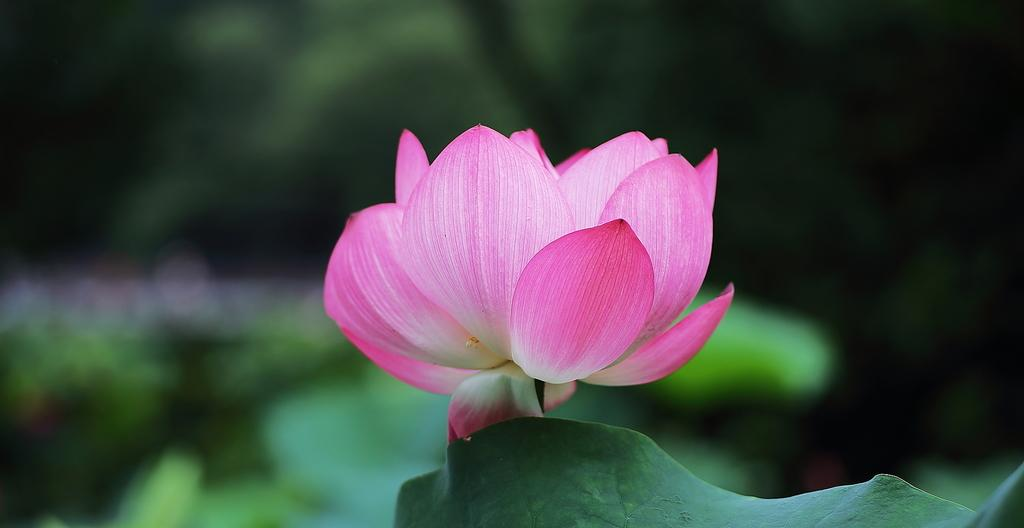What is the main subject in the center of the image? There is a lotus flower in the center of the image. What other part of the lotus plant can be seen in the image? There is a lotus leaf at the bottom of the image. How would you describe the background of the image? The background of the image is blurred. What type of haircut does the duck have in the image? There is no duck present in the image, so it is not possible to answer that question. 